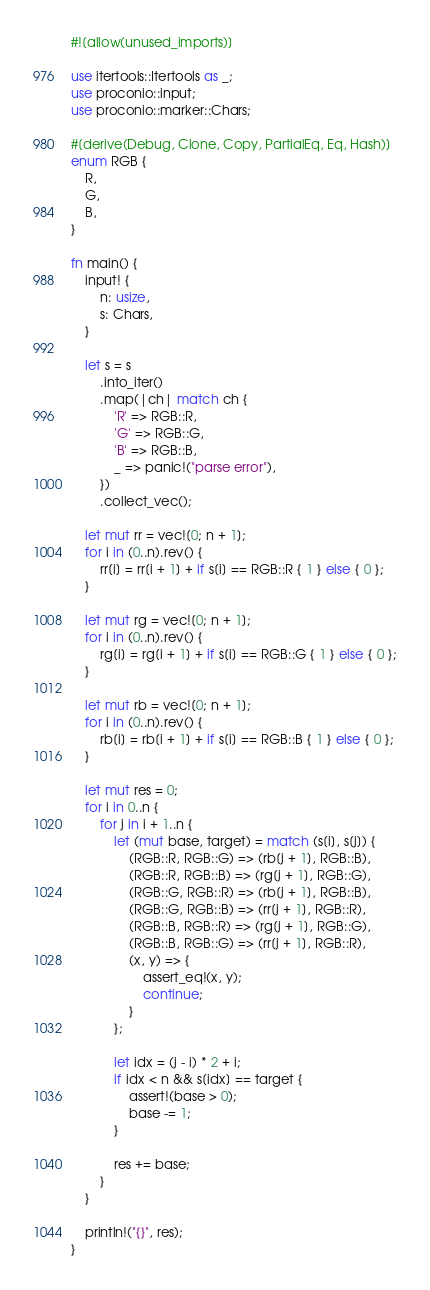Convert code to text. <code><loc_0><loc_0><loc_500><loc_500><_Rust_>#![allow(unused_imports)]

use itertools::Itertools as _;
use proconio::input;
use proconio::marker::Chars;

#[derive(Debug, Clone, Copy, PartialEq, Eq, Hash)]
enum RGB {
    R,
    G,
    B,
}

fn main() {
    input! {
        n: usize,
        s: Chars,
    }

    let s = s
        .into_iter()
        .map(|ch| match ch {
            'R' => RGB::R,
            'G' => RGB::G,
            'B' => RGB::B,
            _ => panic!("parse error"),
        })
        .collect_vec();

    let mut rr = vec![0; n + 1];
    for i in (0..n).rev() {
        rr[i] = rr[i + 1] + if s[i] == RGB::R { 1 } else { 0 };
    }

    let mut rg = vec![0; n + 1];
    for i in (0..n).rev() {
        rg[i] = rg[i + 1] + if s[i] == RGB::G { 1 } else { 0 };
    }

    let mut rb = vec![0; n + 1];
    for i in (0..n).rev() {
        rb[i] = rb[i + 1] + if s[i] == RGB::B { 1 } else { 0 };
    }

    let mut res = 0;
    for i in 0..n {
        for j in i + 1..n {
            let (mut base, target) = match (s[i], s[j]) {
                (RGB::R, RGB::G) => (rb[j + 1], RGB::B),
                (RGB::R, RGB::B) => (rg[j + 1], RGB::G),
                (RGB::G, RGB::R) => (rb[j + 1], RGB::B),
                (RGB::G, RGB::B) => (rr[j + 1], RGB::R),
                (RGB::B, RGB::R) => (rg[j + 1], RGB::G),
                (RGB::B, RGB::G) => (rr[j + 1], RGB::R),
                (x, y) => {
                    assert_eq!(x, y);
                    continue;
                }
            };

            let idx = (j - i) * 2 + i;
            if idx < n && s[idx] == target {
                assert!(base > 0);
                base -= 1;
            }

            res += base;
        }
    }

    println!("{}", res);
}
</code> 